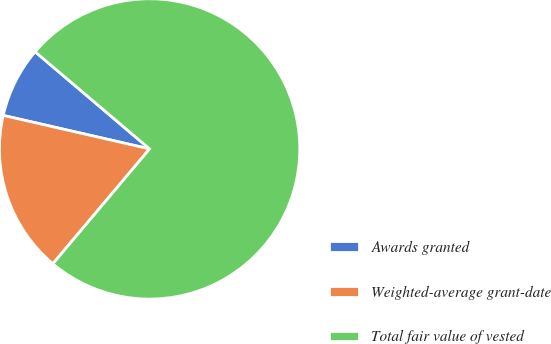Convert chart to OTSL. <chart><loc_0><loc_0><loc_500><loc_500><pie_chart><fcel>Awards granted<fcel>Weighted-average grant-date<fcel>Total fair value of vested<nl><fcel>7.62%<fcel>17.44%<fcel>74.94%<nl></chart> 